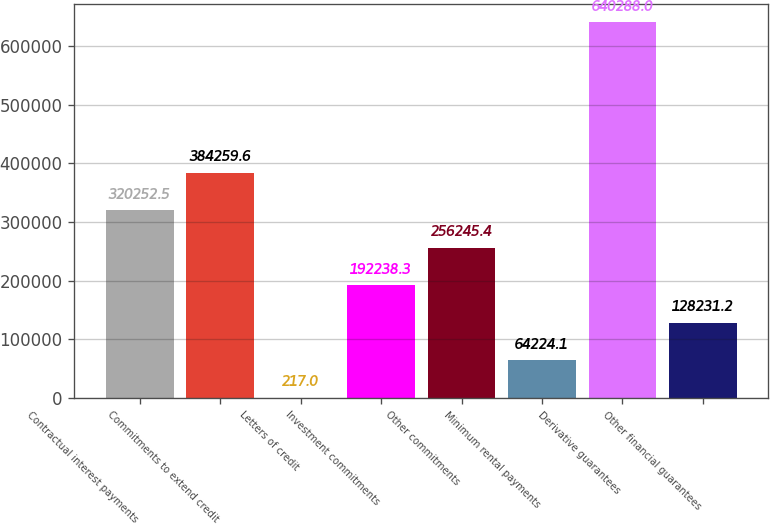Convert chart. <chart><loc_0><loc_0><loc_500><loc_500><bar_chart><fcel>Contractual interest payments<fcel>Commitments to extend credit<fcel>Letters of credit<fcel>Investment commitments<fcel>Other commitments<fcel>Minimum rental payments<fcel>Derivative guarantees<fcel>Other financial guarantees<nl><fcel>320252<fcel>384260<fcel>217<fcel>192238<fcel>256245<fcel>64224.1<fcel>640288<fcel>128231<nl></chart> 